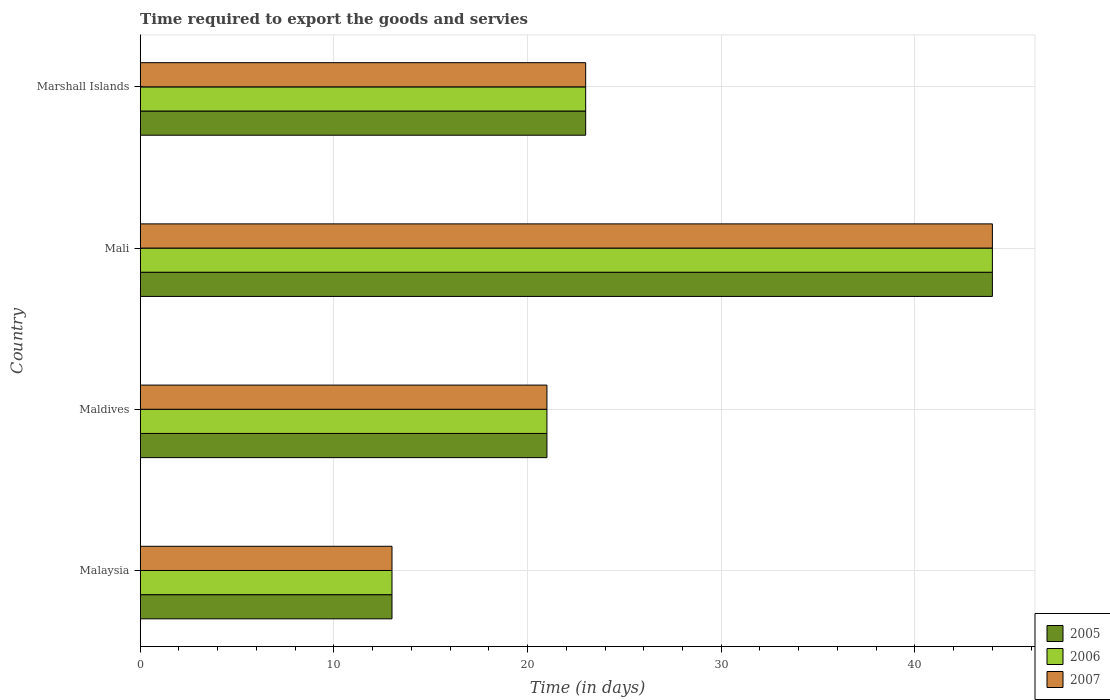Are the number of bars per tick equal to the number of legend labels?
Offer a very short reply. Yes. How many bars are there on the 1st tick from the top?
Offer a terse response. 3. How many bars are there on the 4th tick from the bottom?
Make the answer very short. 3. What is the label of the 2nd group of bars from the top?
Your answer should be compact. Mali. Across all countries, what is the minimum number of days required to export the goods and services in 2007?
Keep it short and to the point. 13. In which country was the number of days required to export the goods and services in 2006 maximum?
Your answer should be very brief. Mali. In which country was the number of days required to export the goods and services in 2005 minimum?
Provide a short and direct response. Malaysia. What is the total number of days required to export the goods and services in 2005 in the graph?
Your answer should be compact. 101. What is the difference between the number of days required to export the goods and services in 2006 in Mali and that in Marshall Islands?
Provide a short and direct response. 21. What is the average number of days required to export the goods and services in 2006 per country?
Make the answer very short. 25.25. What is the difference between the number of days required to export the goods and services in 2007 and number of days required to export the goods and services in 2005 in Malaysia?
Provide a succinct answer. 0. What is the ratio of the number of days required to export the goods and services in 2005 in Mali to that in Marshall Islands?
Provide a short and direct response. 1.91. Is the number of days required to export the goods and services in 2006 in Malaysia less than that in Maldives?
Make the answer very short. Yes. Is the difference between the number of days required to export the goods and services in 2007 in Maldives and Mali greater than the difference between the number of days required to export the goods and services in 2005 in Maldives and Mali?
Ensure brevity in your answer.  No. What is the difference between the highest and the second highest number of days required to export the goods and services in 2006?
Offer a very short reply. 21. In how many countries, is the number of days required to export the goods and services in 2005 greater than the average number of days required to export the goods and services in 2005 taken over all countries?
Your answer should be very brief. 1. Is the sum of the number of days required to export the goods and services in 2005 in Maldives and Marshall Islands greater than the maximum number of days required to export the goods and services in 2007 across all countries?
Provide a short and direct response. No. How many bars are there?
Provide a succinct answer. 12. What is the difference between two consecutive major ticks on the X-axis?
Offer a very short reply. 10. Does the graph contain any zero values?
Offer a terse response. No. Where does the legend appear in the graph?
Your response must be concise. Bottom right. How are the legend labels stacked?
Your response must be concise. Vertical. What is the title of the graph?
Provide a short and direct response. Time required to export the goods and servies. What is the label or title of the X-axis?
Make the answer very short. Time (in days). What is the label or title of the Y-axis?
Give a very brief answer. Country. What is the Time (in days) of 2005 in Malaysia?
Provide a succinct answer. 13. What is the Time (in days) of 2006 in Malaysia?
Offer a terse response. 13. What is the Time (in days) in 2006 in Maldives?
Provide a short and direct response. 21. What is the Time (in days) of 2007 in Maldives?
Offer a very short reply. 21. What is the Time (in days) in 2006 in Mali?
Provide a short and direct response. 44. What is the Time (in days) of 2007 in Mali?
Offer a very short reply. 44. What is the Time (in days) in 2006 in Marshall Islands?
Offer a very short reply. 23. Across all countries, what is the minimum Time (in days) in 2007?
Your answer should be compact. 13. What is the total Time (in days) in 2005 in the graph?
Offer a very short reply. 101. What is the total Time (in days) in 2006 in the graph?
Give a very brief answer. 101. What is the total Time (in days) in 2007 in the graph?
Offer a very short reply. 101. What is the difference between the Time (in days) of 2006 in Malaysia and that in Maldives?
Make the answer very short. -8. What is the difference between the Time (in days) of 2005 in Malaysia and that in Mali?
Offer a terse response. -31. What is the difference between the Time (in days) in 2006 in Malaysia and that in Mali?
Provide a short and direct response. -31. What is the difference between the Time (in days) in 2007 in Malaysia and that in Mali?
Provide a short and direct response. -31. What is the difference between the Time (in days) of 2005 in Malaysia and that in Marshall Islands?
Your answer should be very brief. -10. What is the difference between the Time (in days) of 2007 in Malaysia and that in Marshall Islands?
Your answer should be compact. -10. What is the difference between the Time (in days) in 2005 in Maldives and that in Mali?
Offer a very short reply. -23. What is the difference between the Time (in days) of 2006 in Maldives and that in Mali?
Your answer should be very brief. -23. What is the difference between the Time (in days) of 2005 in Maldives and that in Marshall Islands?
Give a very brief answer. -2. What is the difference between the Time (in days) in 2005 in Mali and that in Marshall Islands?
Offer a terse response. 21. What is the difference between the Time (in days) in 2005 in Malaysia and the Time (in days) in 2006 in Maldives?
Your answer should be very brief. -8. What is the difference between the Time (in days) in 2005 in Malaysia and the Time (in days) in 2007 in Maldives?
Offer a very short reply. -8. What is the difference between the Time (in days) of 2005 in Malaysia and the Time (in days) of 2006 in Mali?
Provide a succinct answer. -31. What is the difference between the Time (in days) in 2005 in Malaysia and the Time (in days) in 2007 in Mali?
Your response must be concise. -31. What is the difference between the Time (in days) in 2006 in Malaysia and the Time (in days) in 2007 in Mali?
Offer a terse response. -31. What is the difference between the Time (in days) of 2005 in Malaysia and the Time (in days) of 2006 in Marshall Islands?
Your answer should be very brief. -10. What is the difference between the Time (in days) in 2005 in Malaysia and the Time (in days) in 2007 in Marshall Islands?
Make the answer very short. -10. What is the difference between the Time (in days) in 2006 in Malaysia and the Time (in days) in 2007 in Marshall Islands?
Ensure brevity in your answer.  -10. What is the difference between the Time (in days) in 2005 in Maldives and the Time (in days) in 2007 in Marshall Islands?
Provide a short and direct response. -2. What is the difference between the Time (in days) in 2006 in Maldives and the Time (in days) in 2007 in Marshall Islands?
Your response must be concise. -2. What is the difference between the Time (in days) of 2005 in Mali and the Time (in days) of 2006 in Marshall Islands?
Ensure brevity in your answer.  21. What is the difference between the Time (in days) in 2005 in Mali and the Time (in days) in 2007 in Marshall Islands?
Make the answer very short. 21. What is the difference between the Time (in days) of 2006 in Mali and the Time (in days) of 2007 in Marshall Islands?
Your response must be concise. 21. What is the average Time (in days) of 2005 per country?
Keep it short and to the point. 25.25. What is the average Time (in days) of 2006 per country?
Make the answer very short. 25.25. What is the average Time (in days) of 2007 per country?
Give a very brief answer. 25.25. What is the difference between the Time (in days) in 2005 and Time (in days) in 2006 in Malaysia?
Offer a very short reply. 0. What is the difference between the Time (in days) of 2005 and Time (in days) of 2006 in Maldives?
Ensure brevity in your answer.  0. What is the difference between the Time (in days) of 2005 and Time (in days) of 2007 in Maldives?
Ensure brevity in your answer.  0. What is the difference between the Time (in days) of 2006 and Time (in days) of 2007 in Maldives?
Make the answer very short. 0. What is the difference between the Time (in days) in 2005 and Time (in days) in 2006 in Mali?
Keep it short and to the point. 0. What is the difference between the Time (in days) of 2006 and Time (in days) of 2007 in Mali?
Your answer should be very brief. 0. What is the difference between the Time (in days) in 2005 and Time (in days) in 2006 in Marshall Islands?
Provide a succinct answer. 0. What is the difference between the Time (in days) in 2005 and Time (in days) in 2007 in Marshall Islands?
Ensure brevity in your answer.  0. What is the difference between the Time (in days) of 2006 and Time (in days) of 2007 in Marshall Islands?
Your answer should be very brief. 0. What is the ratio of the Time (in days) in 2005 in Malaysia to that in Maldives?
Keep it short and to the point. 0.62. What is the ratio of the Time (in days) of 2006 in Malaysia to that in Maldives?
Your answer should be compact. 0.62. What is the ratio of the Time (in days) in 2007 in Malaysia to that in Maldives?
Your response must be concise. 0.62. What is the ratio of the Time (in days) of 2005 in Malaysia to that in Mali?
Offer a terse response. 0.3. What is the ratio of the Time (in days) of 2006 in Malaysia to that in Mali?
Your answer should be compact. 0.3. What is the ratio of the Time (in days) of 2007 in Malaysia to that in Mali?
Your answer should be very brief. 0.3. What is the ratio of the Time (in days) of 2005 in Malaysia to that in Marshall Islands?
Make the answer very short. 0.57. What is the ratio of the Time (in days) in 2006 in Malaysia to that in Marshall Islands?
Ensure brevity in your answer.  0.57. What is the ratio of the Time (in days) in 2007 in Malaysia to that in Marshall Islands?
Give a very brief answer. 0.57. What is the ratio of the Time (in days) in 2005 in Maldives to that in Mali?
Give a very brief answer. 0.48. What is the ratio of the Time (in days) of 2006 in Maldives to that in Mali?
Your response must be concise. 0.48. What is the ratio of the Time (in days) in 2007 in Maldives to that in Mali?
Your response must be concise. 0.48. What is the ratio of the Time (in days) in 2005 in Maldives to that in Marshall Islands?
Your answer should be compact. 0.91. What is the ratio of the Time (in days) in 2005 in Mali to that in Marshall Islands?
Your response must be concise. 1.91. What is the ratio of the Time (in days) in 2006 in Mali to that in Marshall Islands?
Provide a succinct answer. 1.91. What is the ratio of the Time (in days) in 2007 in Mali to that in Marshall Islands?
Provide a succinct answer. 1.91. What is the difference between the highest and the second highest Time (in days) in 2007?
Your answer should be compact. 21. What is the difference between the highest and the lowest Time (in days) of 2007?
Keep it short and to the point. 31. 